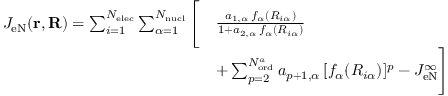<formula> <loc_0><loc_0><loc_500><loc_500>\begin{array} { r l } { J _ { e N } ( r , R ) = \sum _ { i = 1 } ^ { N _ { e l e c } } \sum _ { \alpha = 1 } ^ { N _ { n u c l } } \left [ } & { \frac { a _ { 1 , \alpha } \, f _ { \alpha } ( R _ { i \alpha } ) } { 1 + a _ { 2 , \alpha } \, f _ { \alpha } ( R _ { i \alpha } ) } } \\ & { + \sum _ { p = 2 } ^ { N _ { o r d } ^ { a } } a _ { p + 1 , \alpha } \, [ f _ { \alpha } ( R _ { i \alpha } ) ] ^ { p } - J _ { e N } ^ { \infty } \right ] } \end{array}</formula> 